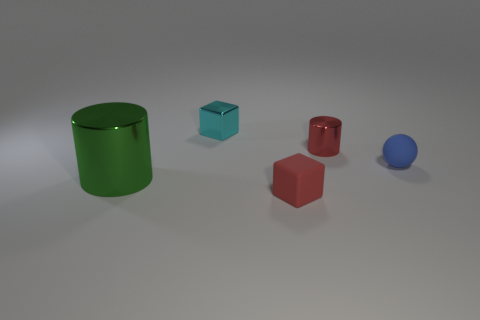How many metallic objects are either blocks or small blue balls?
Give a very brief answer. 1. Are there any other tiny spheres made of the same material as the blue ball?
Your answer should be very brief. No. What is the green cylinder made of?
Your response must be concise. Metal. The tiny red object that is in front of the small shiny thing right of the small block behind the big green thing is what shape?
Make the answer very short. Cube. Are there more small cyan cubes that are right of the blue matte object than big brown matte cubes?
Provide a short and direct response. No. There is a red shiny object; is its shape the same as the metal object in front of the small red shiny object?
Give a very brief answer. Yes. What shape is the tiny matte thing that is the same color as the tiny cylinder?
Keep it short and to the point. Cube. There is a tiny red object to the left of the cylinder to the right of the tiny cyan object; how many blocks are on the left side of it?
Offer a very short reply. 1. What is the color of the cylinder that is the same size as the cyan thing?
Your answer should be very brief. Red. There is a cylinder that is to the left of the red thing in front of the green metal thing; how big is it?
Make the answer very short. Large. 